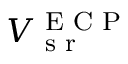Convert formula to latex. <formula><loc_0><loc_0><loc_500><loc_500>V _ { s r } ^ { E C P }</formula> 